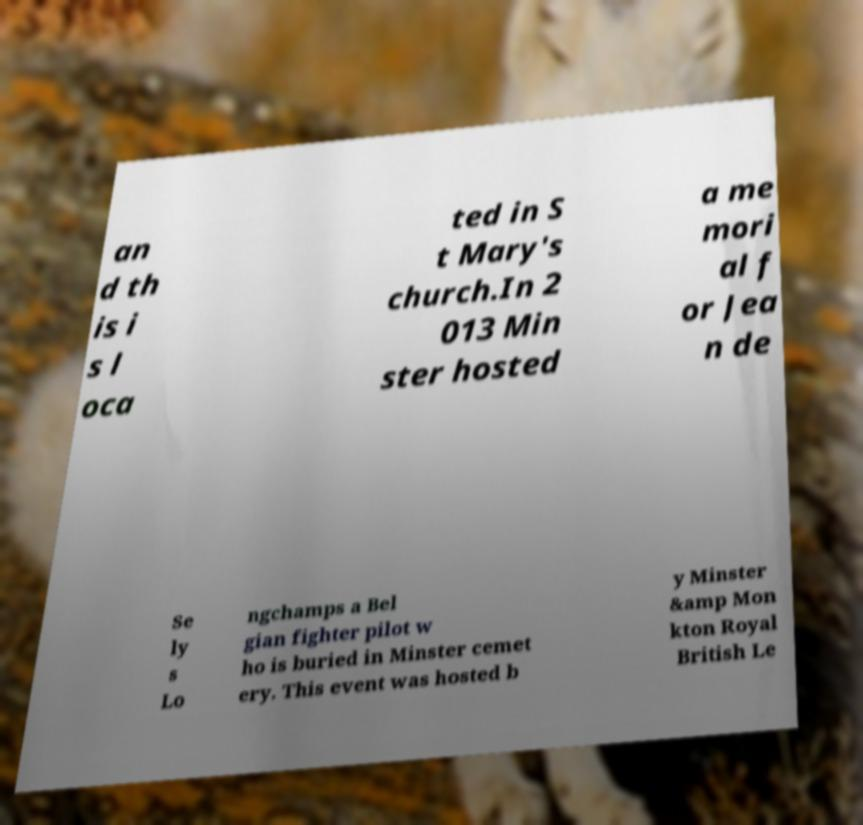I need the written content from this picture converted into text. Can you do that? an d th is i s l oca ted in S t Mary's church.In 2 013 Min ster hosted a me mori al f or Jea n de Se ly s Lo ngchamps a Bel gian fighter pilot w ho is buried in Minster cemet ery. This event was hosted b y Minster &amp Mon kton Royal British Le 